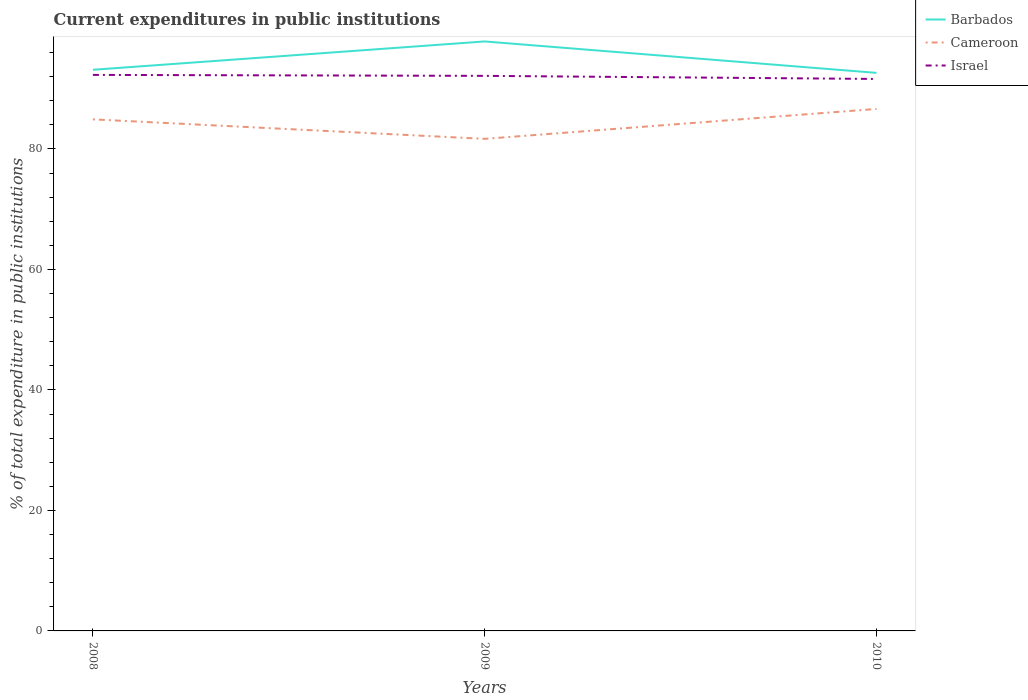How many different coloured lines are there?
Ensure brevity in your answer.  3. Is the number of lines equal to the number of legend labels?
Ensure brevity in your answer.  Yes. Across all years, what is the maximum current expenditures in public institutions in Cameroon?
Your answer should be compact. 81.68. What is the total current expenditures in public institutions in Barbados in the graph?
Keep it short and to the point. 5.22. What is the difference between the highest and the second highest current expenditures in public institutions in Cameroon?
Keep it short and to the point. 4.97. What is the difference between the highest and the lowest current expenditures in public institutions in Barbados?
Offer a very short reply. 1. Is the current expenditures in public institutions in Barbados strictly greater than the current expenditures in public institutions in Israel over the years?
Keep it short and to the point. No. How many lines are there?
Make the answer very short. 3. Are the values on the major ticks of Y-axis written in scientific E-notation?
Give a very brief answer. No. Does the graph contain grids?
Offer a terse response. No. Where does the legend appear in the graph?
Your answer should be very brief. Top right. How many legend labels are there?
Offer a terse response. 3. How are the legend labels stacked?
Your answer should be compact. Vertical. What is the title of the graph?
Provide a succinct answer. Current expenditures in public institutions. What is the label or title of the X-axis?
Your answer should be compact. Years. What is the label or title of the Y-axis?
Provide a short and direct response. % of total expenditure in public institutions. What is the % of total expenditure in public institutions in Barbados in 2008?
Your answer should be compact. 93.14. What is the % of total expenditure in public institutions of Cameroon in 2008?
Ensure brevity in your answer.  84.91. What is the % of total expenditure in public institutions in Israel in 2008?
Offer a terse response. 92.29. What is the % of total expenditure in public institutions of Barbados in 2009?
Make the answer very short. 97.85. What is the % of total expenditure in public institutions in Cameroon in 2009?
Ensure brevity in your answer.  81.68. What is the % of total expenditure in public institutions of Israel in 2009?
Offer a very short reply. 92.13. What is the % of total expenditure in public institutions of Barbados in 2010?
Give a very brief answer. 92.63. What is the % of total expenditure in public institutions of Cameroon in 2010?
Give a very brief answer. 86.64. What is the % of total expenditure in public institutions in Israel in 2010?
Make the answer very short. 91.62. Across all years, what is the maximum % of total expenditure in public institutions in Barbados?
Your answer should be very brief. 97.85. Across all years, what is the maximum % of total expenditure in public institutions in Cameroon?
Your answer should be compact. 86.64. Across all years, what is the maximum % of total expenditure in public institutions in Israel?
Offer a terse response. 92.29. Across all years, what is the minimum % of total expenditure in public institutions of Barbados?
Provide a short and direct response. 92.63. Across all years, what is the minimum % of total expenditure in public institutions of Cameroon?
Your answer should be compact. 81.68. Across all years, what is the minimum % of total expenditure in public institutions in Israel?
Keep it short and to the point. 91.62. What is the total % of total expenditure in public institutions in Barbados in the graph?
Ensure brevity in your answer.  283.62. What is the total % of total expenditure in public institutions of Cameroon in the graph?
Keep it short and to the point. 253.24. What is the total % of total expenditure in public institutions in Israel in the graph?
Offer a terse response. 276.05. What is the difference between the % of total expenditure in public institutions of Barbados in 2008 and that in 2009?
Offer a terse response. -4.7. What is the difference between the % of total expenditure in public institutions in Cameroon in 2008 and that in 2009?
Make the answer very short. 3.24. What is the difference between the % of total expenditure in public institutions of Israel in 2008 and that in 2009?
Your response must be concise. 0.16. What is the difference between the % of total expenditure in public institutions in Barbados in 2008 and that in 2010?
Give a very brief answer. 0.51. What is the difference between the % of total expenditure in public institutions of Cameroon in 2008 and that in 2010?
Keep it short and to the point. -1.73. What is the difference between the % of total expenditure in public institutions in Israel in 2008 and that in 2010?
Your response must be concise. 0.67. What is the difference between the % of total expenditure in public institutions in Barbados in 2009 and that in 2010?
Keep it short and to the point. 5.22. What is the difference between the % of total expenditure in public institutions of Cameroon in 2009 and that in 2010?
Keep it short and to the point. -4.97. What is the difference between the % of total expenditure in public institutions in Israel in 2009 and that in 2010?
Provide a succinct answer. 0.51. What is the difference between the % of total expenditure in public institutions of Barbados in 2008 and the % of total expenditure in public institutions of Cameroon in 2009?
Ensure brevity in your answer.  11.46. What is the difference between the % of total expenditure in public institutions in Cameroon in 2008 and the % of total expenditure in public institutions in Israel in 2009?
Ensure brevity in your answer.  -7.22. What is the difference between the % of total expenditure in public institutions in Barbados in 2008 and the % of total expenditure in public institutions in Cameroon in 2010?
Provide a short and direct response. 6.5. What is the difference between the % of total expenditure in public institutions of Barbados in 2008 and the % of total expenditure in public institutions of Israel in 2010?
Your answer should be compact. 1.52. What is the difference between the % of total expenditure in public institutions of Cameroon in 2008 and the % of total expenditure in public institutions of Israel in 2010?
Offer a terse response. -6.71. What is the difference between the % of total expenditure in public institutions in Barbados in 2009 and the % of total expenditure in public institutions in Cameroon in 2010?
Your response must be concise. 11.2. What is the difference between the % of total expenditure in public institutions of Barbados in 2009 and the % of total expenditure in public institutions of Israel in 2010?
Offer a very short reply. 6.23. What is the difference between the % of total expenditure in public institutions of Cameroon in 2009 and the % of total expenditure in public institutions of Israel in 2010?
Make the answer very short. -9.94. What is the average % of total expenditure in public institutions of Barbados per year?
Your answer should be very brief. 94.54. What is the average % of total expenditure in public institutions of Cameroon per year?
Offer a terse response. 84.41. What is the average % of total expenditure in public institutions of Israel per year?
Offer a very short reply. 92.02. In the year 2008, what is the difference between the % of total expenditure in public institutions in Barbados and % of total expenditure in public institutions in Cameroon?
Provide a short and direct response. 8.23. In the year 2008, what is the difference between the % of total expenditure in public institutions of Barbados and % of total expenditure in public institutions of Israel?
Provide a short and direct response. 0.85. In the year 2008, what is the difference between the % of total expenditure in public institutions in Cameroon and % of total expenditure in public institutions in Israel?
Offer a very short reply. -7.38. In the year 2009, what is the difference between the % of total expenditure in public institutions of Barbados and % of total expenditure in public institutions of Cameroon?
Make the answer very short. 16.17. In the year 2009, what is the difference between the % of total expenditure in public institutions of Barbados and % of total expenditure in public institutions of Israel?
Offer a very short reply. 5.71. In the year 2009, what is the difference between the % of total expenditure in public institutions of Cameroon and % of total expenditure in public institutions of Israel?
Provide a succinct answer. -10.46. In the year 2010, what is the difference between the % of total expenditure in public institutions of Barbados and % of total expenditure in public institutions of Cameroon?
Keep it short and to the point. 5.99. In the year 2010, what is the difference between the % of total expenditure in public institutions of Barbados and % of total expenditure in public institutions of Israel?
Your answer should be very brief. 1.01. In the year 2010, what is the difference between the % of total expenditure in public institutions of Cameroon and % of total expenditure in public institutions of Israel?
Offer a terse response. -4.98. What is the ratio of the % of total expenditure in public institutions of Barbados in 2008 to that in 2009?
Your answer should be very brief. 0.95. What is the ratio of the % of total expenditure in public institutions of Cameroon in 2008 to that in 2009?
Provide a short and direct response. 1.04. What is the ratio of the % of total expenditure in public institutions in Barbados in 2008 to that in 2010?
Make the answer very short. 1.01. What is the ratio of the % of total expenditure in public institutions of Cameroon in 2008 to that in 2010?
Your answer should be compact. 0.98. What is the ratio of the % of total expenditure in public institutions in Israel in 2008 to that in 2010?
Provide a short and direct response. 1.01. What is the ratio of the % of total expenditure in public institutions of Barbados in 2009 to that in 2010?
Your response must be concise. 1.06. What is the ratio of the % of total expenditure in public institutions in Cameroon in 2009 to that in 2010?
Offer a very short reply. 0.94. What is the ratio of the % of total expenditure in public institutions of Israel in 2009 to that in 2010?
Provide a short and direct response. 1.01. What is the difference between the highest and the second highest % of total expenditure in public institutions of Barbados?
Your response must be concise. 4.7. What is the difference between the highest and the second highest % of total expenditure in public institutions in Cameroon?
Your answer should be compact. 1.73. What is the difference between the highest and the second highest % of total expenditure in public institutions in Israel?
Offer a terse response. 0.16. What is the difference between the highest and the lowest % of total expenditure in public institutions in Barbados?
Provide a short and direct response. 5.22. What is the difference between the highest and the lowest % of total expenditure in public institutions of Cameroon?
Give a very brief answer. 4.97. What is the difference between the highest and the lowest % of total expenditure in public institutions in Israel?
Give a very brief answer. 0.67. 